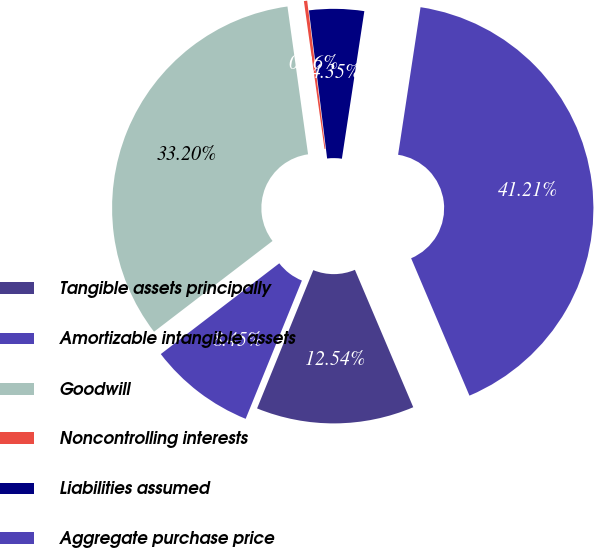Convert chart to OTSL. <chart><loc_0><loc_0><loc_500><loc_500><pie_chart><fcel>Tangible assets principally<fcel>Amortizable intangible assets<fcel>Goodwill<fcel>Noncontrolling interests<fcel>Liabilities assumed<fcel>Aggregate purchase price<nl><fcel>12.54%<fcel>8.45%<fcel>33.2%<fcel>0.26%<fcel>4.35%<fcel>41.21%<nl></chart> 